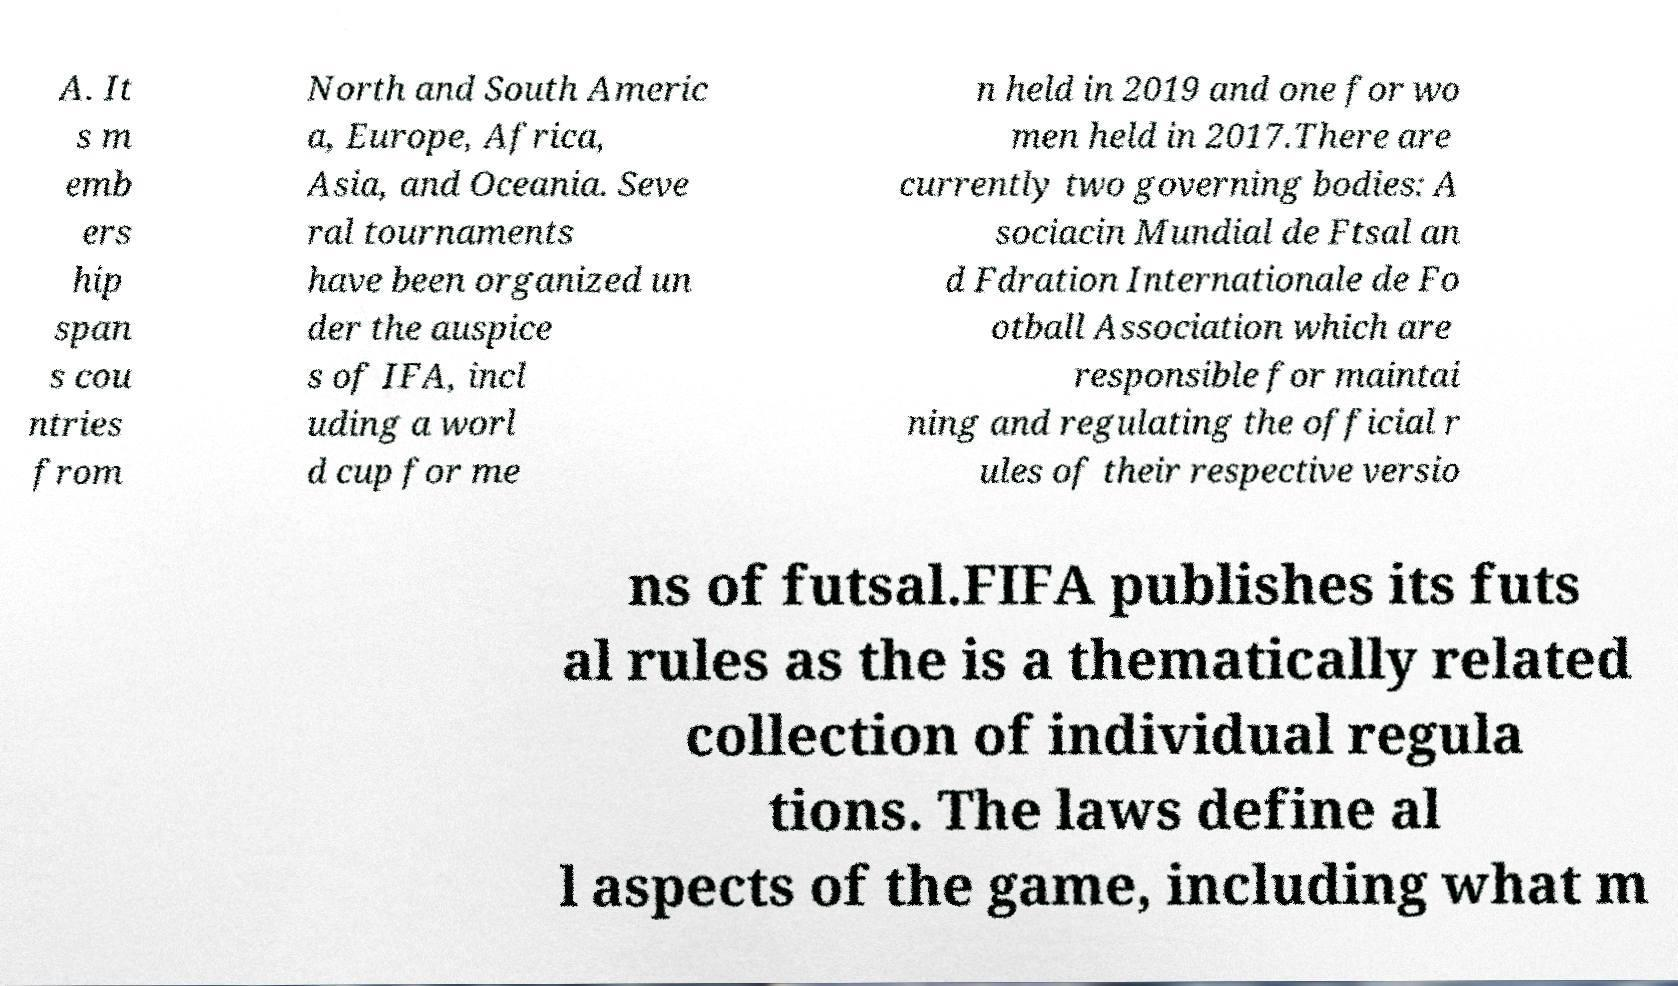What messages or text are displayed in this image? I need them in a readable, typed format. A. It s m emb ers hip span s cou ntries from North and South Americ a, Europe, Africa, Asia, and Oceania. Seve ral tournaments have been organized un der the auspice s of IFA, incl uding a worl d cup for me n held in 2019 and one for wo men held in 2017.There are currently two governing bodies: A sociacin Mundial de Ftsal an d Fdration Internationale de Fo otball Association which are responsible for maintai ning and regulating the official r ules of their respective versio ns of futsal.FIFA publishes its futs al rules as the is a thematically related collection of individual regula tions. The laws define al l aspects of the game, including what m 